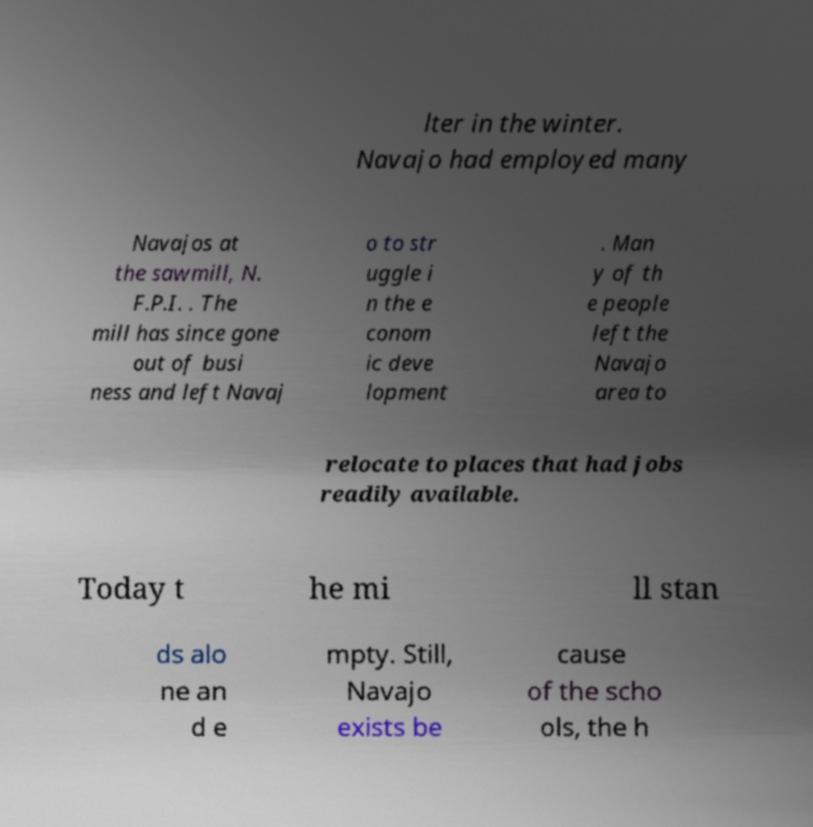For documentation purposes, I need the text within this image transcribed. Could you provide that? lter in the winter. Navajo had employed many Navajos at the sawmill, N. F.P.I. . The mill has since gone out of busi ness and left Navaj o to str uggle i n the e conom ic deve lopment . Man y of th e people left the Navajo area to relocate to places that had jobs readily available. Today t he mi ll stan ds alo ne an d e mpty. Still, Navajo exists be cause of the scho ols, the h 